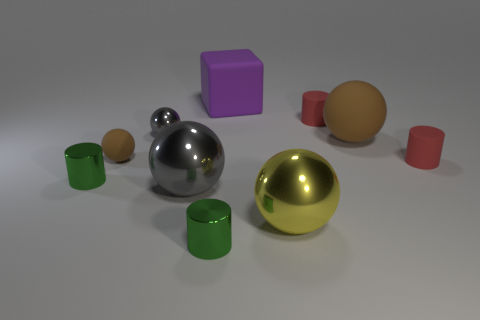Are there an equal number of big objects and tiny rubber objects?
Your answer should be compact. No. Do the yellow sphere and the cube have the same size?
Your answer should be very brief. Yes. Is there a cylinder on the left side of the metallic thing behind the tiny red thing in front of the tiny brown thing?
Your answer should be very brief. Yes. What is the size of the purple thing?
Offer a terse response. Large. What number of red cylinders have the same size as the purple matte block?
Your answer should be very brief. 0. What material is the yellow thing that is the same shape as the small brown object?
Give a very brief answer. Metal. There is a rubber object that is left of the large brown thing and in front of the small gray metal object; what is its shape?
Your response must be concise. Sphere. The tiny red matte object that is behind the small gray object has what shape?
Keep it short and to the point. Cylinder. What number of matte cylinders are behind the tiny brown object and in front of the small brown rubber ball?
Your response must be concise. 0. There is a yellow metal thing; is its size the same as the matte sphere to the right of the large purple matte block?
Give a very brief answer. Yes. 